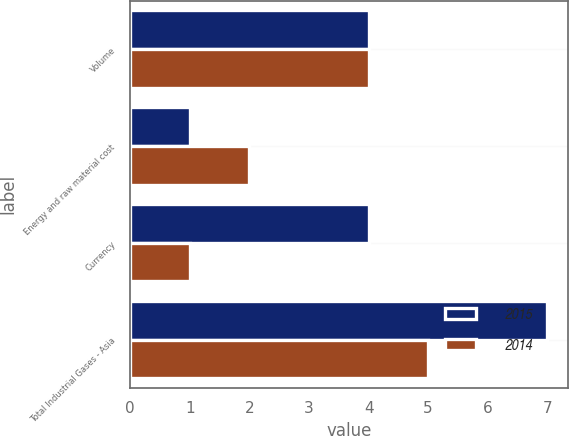Convert chart to OTSL. <chart><loc_0><loc_0><loc_500><loc_500><stacked_bar_chart><ecel><fcel>Volume<fcel>Energy and raw material cost<fcel>Currency<fcel>Total Industrial Gases - Asia<nl><fcel>2015<fcel>4<fcel>1<fcel>4<fcel>7<nl><fcel>2014<fcel>4<fcel>2<fcel>1<fcel>5<nl></chart> 